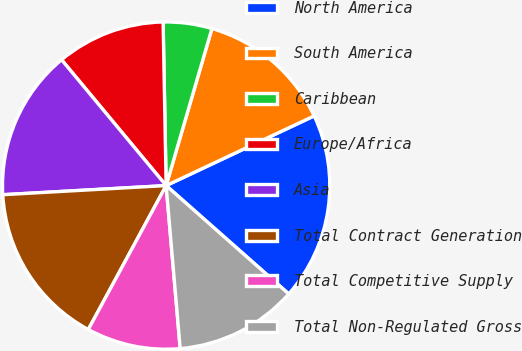Convert chart to OTSL. <chart><loc_0><loc_0><loc_500><loc_500><pie_chart><fcel>North America<fcel>South America<fcel>Caribbean<fcel>Europe/Africa<fcel>Asia<fcel>Total Contract Generation<fcel>Total Competitive Supply<fcel>Total Non-Regulated Gross<nl><fcel>18.52%<fcel>13.48%<fcel>4.81%<fcel>10.74%<fcel>14.85%<fcel>16.22%<fcel>9.26%<fcel>12.11%<nl></chart> 